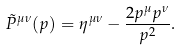Convert formula to latex. <formula><loc_0><loc_0><loc_500><loc_500>\tilde { P } ^ { \mu \nu } ( p ) = \eta ^ { \mu \nu } - \frac { 2 p ^ { \mu } p ^ { \nu } } { p ^ { 2 } } .</formula> 